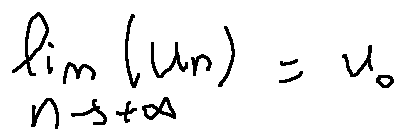Convert formula to latex. <formula><loc_0><loc_0><loc_500><loc_500>\lim \lim i t s _ { n \rightarrow + \infty } ( u _ { n } ) = u _ { 0 }</formula> 